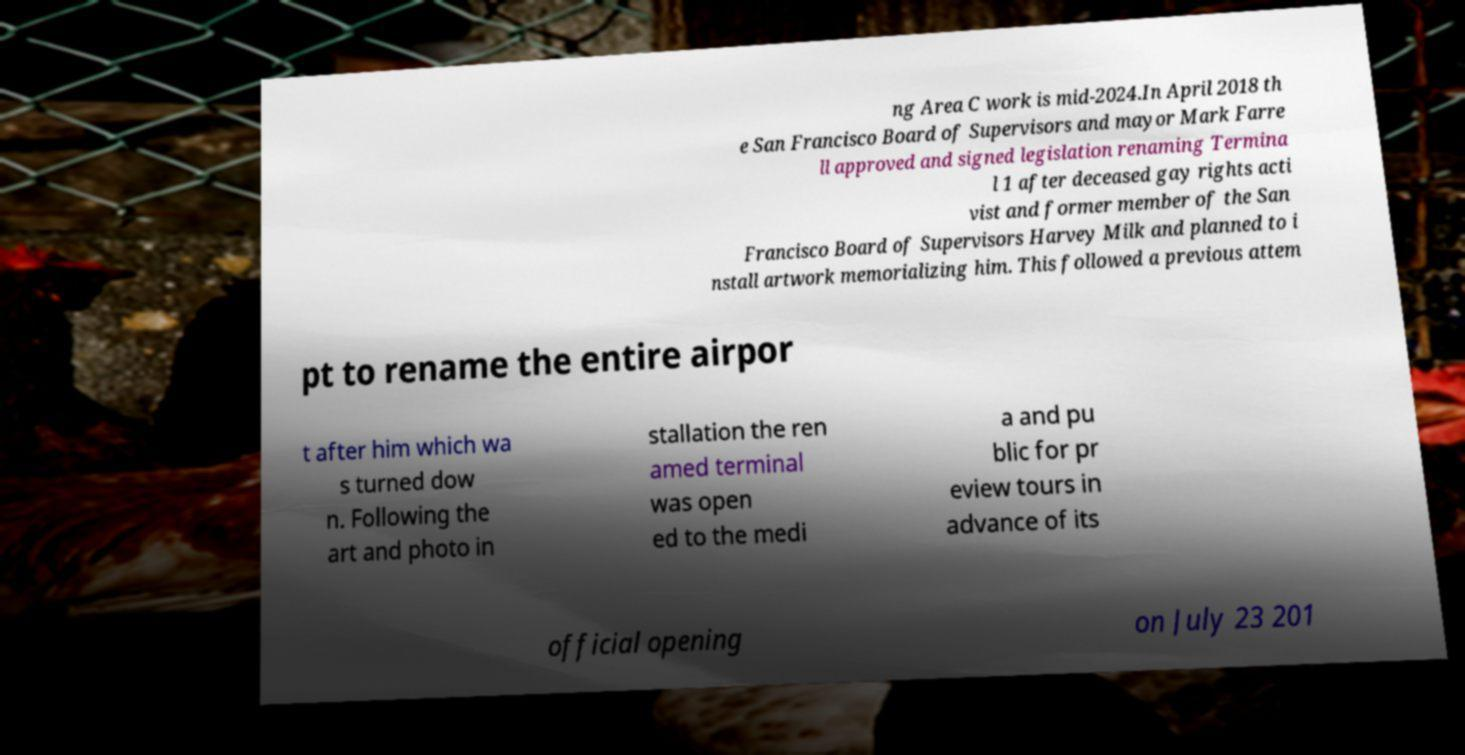Could you assist in decoding the text presented in this image and type it out clearly? ng Area C work is mid-2024.In April 2018 th e San Francisco Board of Supervisors and mayor Mark Farre ll approved and signed legislation renaming Termina l 1 after deceased gay rights acti vist and former member of the San Francisco Board of Supervisors Harvey Milk and planned to i nstall artwork memorializing him. This followed a previous attem pt to rename the entire airpor t after him which wa s turned dow n. Following the art and photo in stallation the ren amed terminal was open ed to the medi a and pu blic for pr eview tours in advance of its official opening on July 23 201 